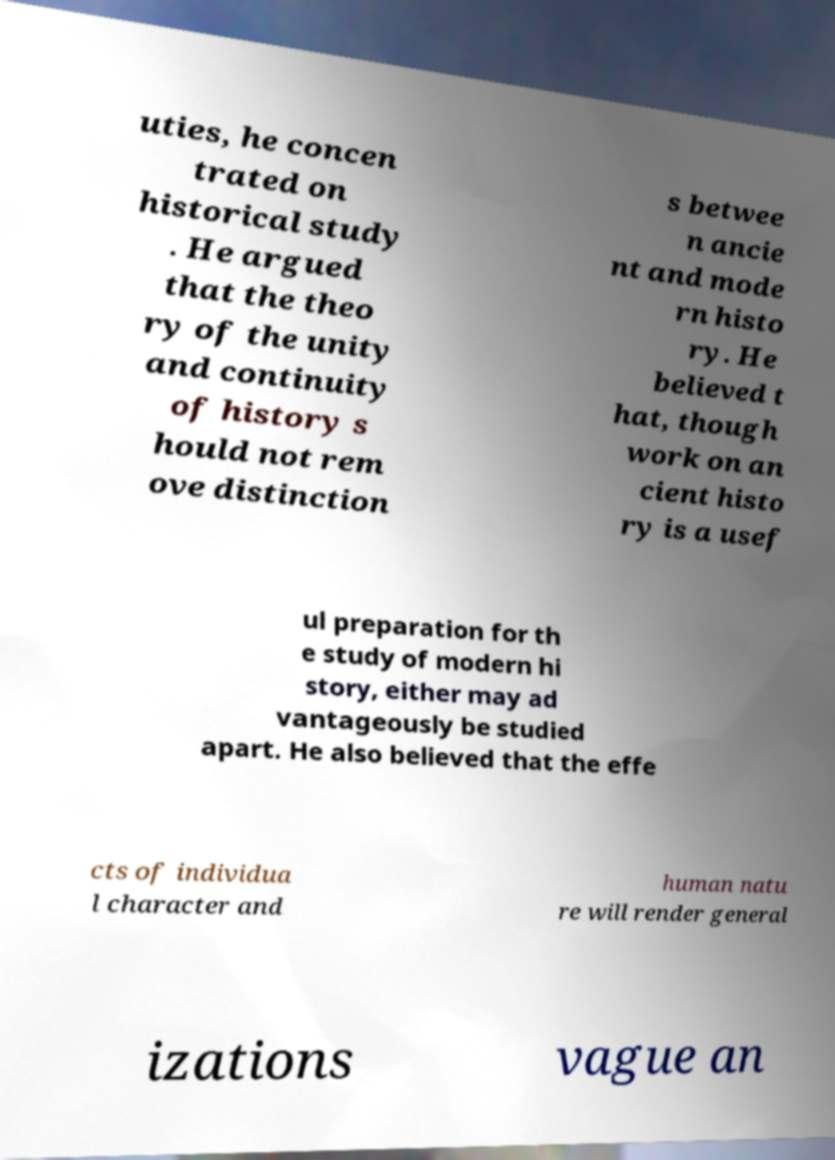Can you read and provide the text displayed in the image?This photo seems to have some interesting text. Can you extract and type it out for me? uties, he concen trated on historical study . He argued that the theo ry of the unity and continuity of history s hould not rem ove distinction s betwee n ancie nt and mode rn histo ry. He believed t hat, though work on an cient histo ry is a usef ul preparation for th e study of modern hi story, either may ad vantageously be studied apart. He also believed that the effe cts of individua l character and human natu re will render general izations vague an 